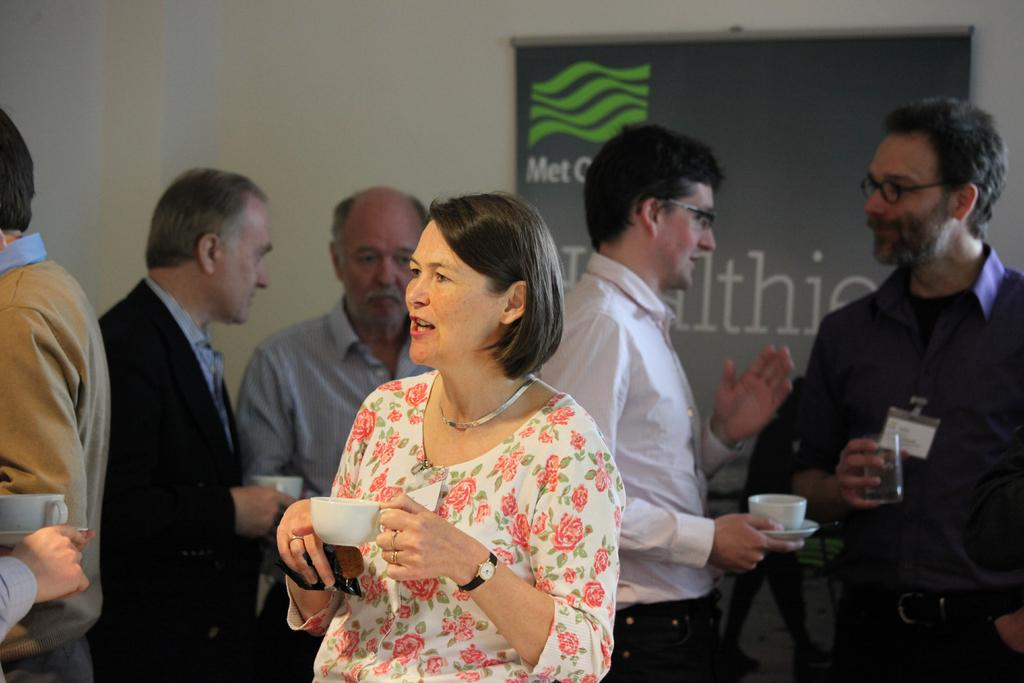Who is the main subject in the image? There is a woman in the image. What is the woman holding in the image? The woman is holding an object and a cup in the image. What is the woman doing in the image? The woman is talking in the image. What can be seen in the background of the image? There are people, a wall, and a banner in the background of the image. What are some of the people in the background doing? Some people in the background are holding objects. What type of fan can be seen in the image? There is no fan present in the image. What does the town smell like in the image? There is no town present in the image, so it is not possible to determine what it might smell like. 